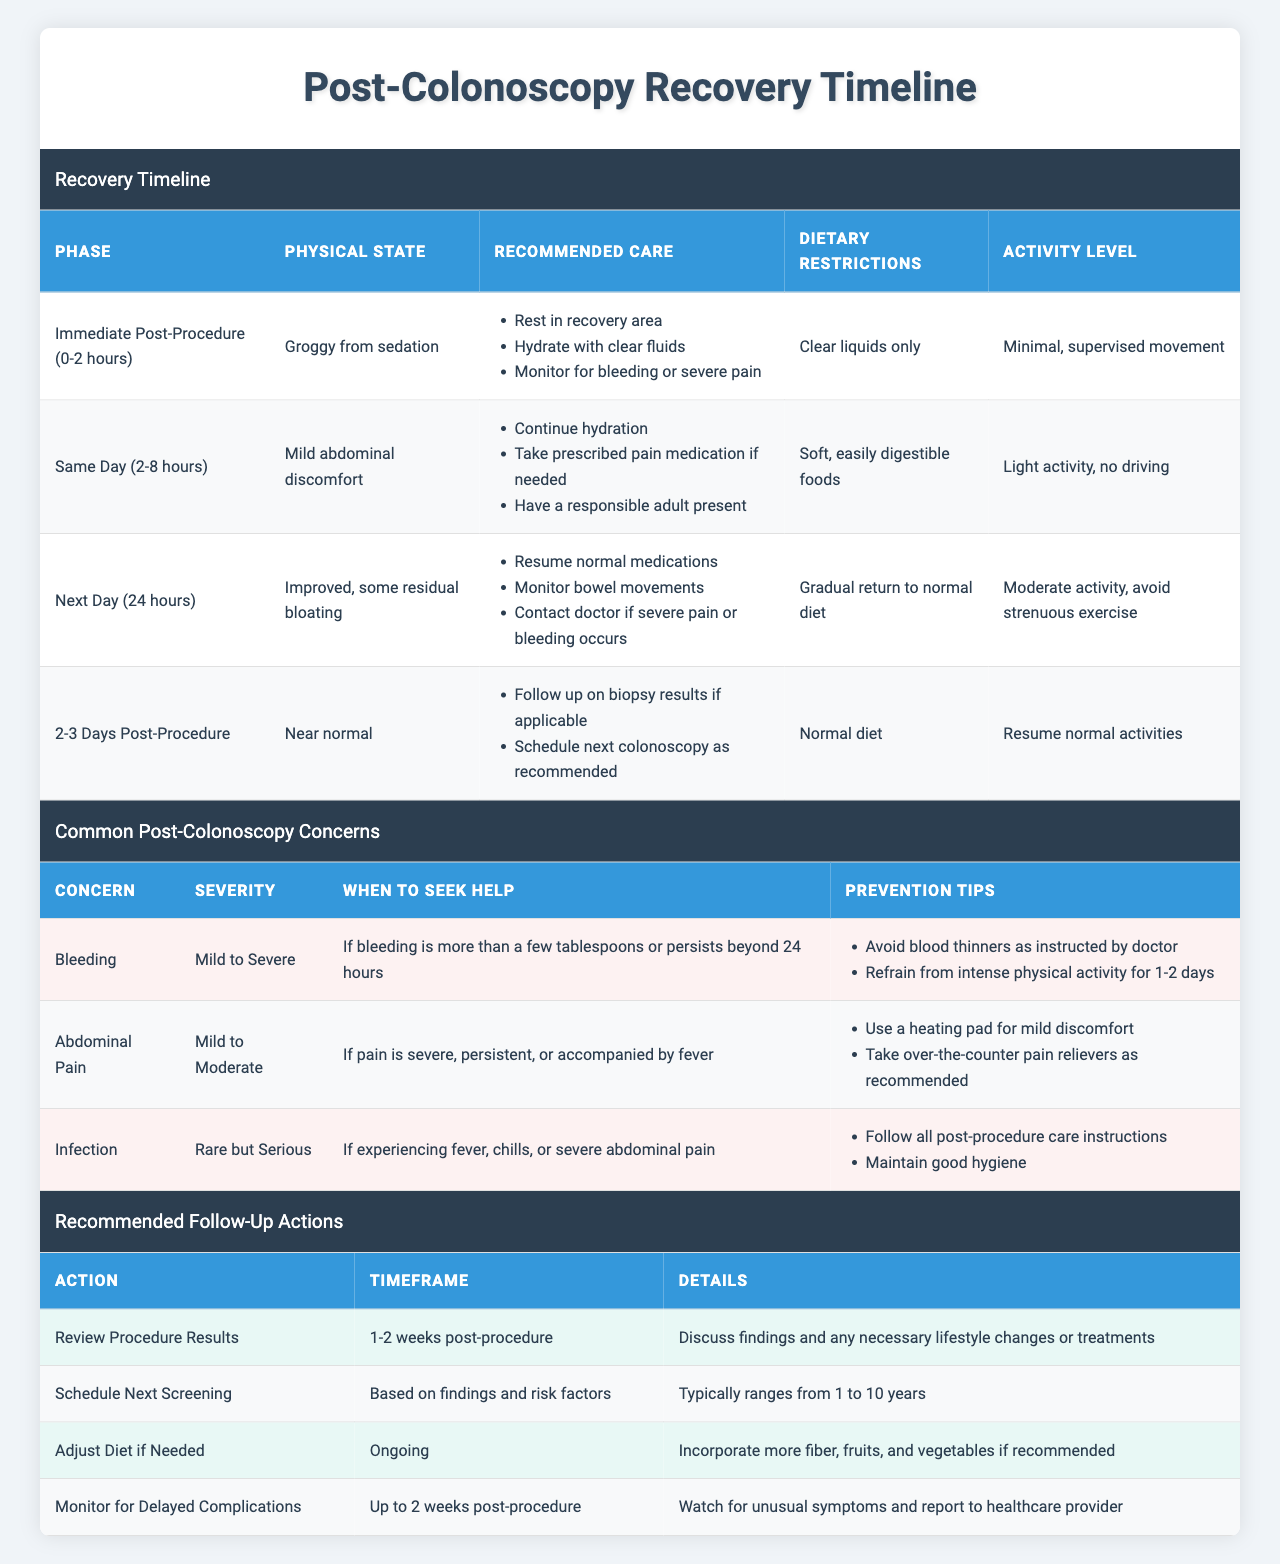What are the recommended care steps during the immediate post-procedure phase? In the table, under the "Immediate Post-Procedure (0-2 hours)" phase, the recommended care steps listed are: Rest in recovery area, Hydrate with clear fluids, and Monitor for bleeding or severe pain.
Answer: Rest, hydrate, and monitor What is the activity level allowed on the same day of the colonoscopy? The table shows that the activity level on the same day (2-8 hours post-procedure) is described as "Light activity, no driving."
Answer: Light activity, no driving Do patients need to seek help for mild abdominal pain? Looking at the "Abdominal Pain" concern, the severity is described as "Mild to Moderate," and help should only be sought if the pain is severe, persistent, or accompanied by fever. This indicates that mild abdominal pain does not typically require medical attention.
Answer: No What dietary restrictions should be followed immediately after the procedure? According to the table, during the immediate post-procedure phase, the dietary restriction is listed as "Clear liquids only."
Answer: Clear liquids only How many days after the procedure does one need to monitor bowel movements? The table states that on the next day (24 hours post-procedure), one should monitor bowel movements as part of the recommended care.
Answer: One day What is the severity of bleeding after the procedure, and when should help be sought? The table categorizes bleeding severity as "Mild to Severe" and suggests seeking help if bleeding is more than a few tablespoons or persists beyond 24 hours.
Answer: Mild to Severe; seek help if excessive or persistent What recommended follow-up actions should be taken 1-2 weeks after the colonoscopy? The table lists "Review Procedure Results" as a recommended follow-up action within 1-2 weeks post-procedure, focusing on discussing findings and necessary lifestyle changes.
Answer: Review Procedure Results If someone experiences abdominal pain, what heating method is suggested for relief? The prevention tips under the "Abdominal Pain" concern in the table advise using a heating pad for mild discomfort.
Answer: Use a heating pad How long should unusual symptoms be monitored post-procedure? The table indicates that unusual symptoms should be monitored for up to 2 weeks post-procedure as part of the recommended follow-up actions.
Answer: Up to 2 weeks Is it necessary to avoid intense physical activity for 1-2 days as a preventive measure for bleeding? The "Bleeding" concern section in the table advises avoidance of intense physical activity for 1-2 days to prevent complications, indicating that it is indeed necessary.
Answer: Yes 